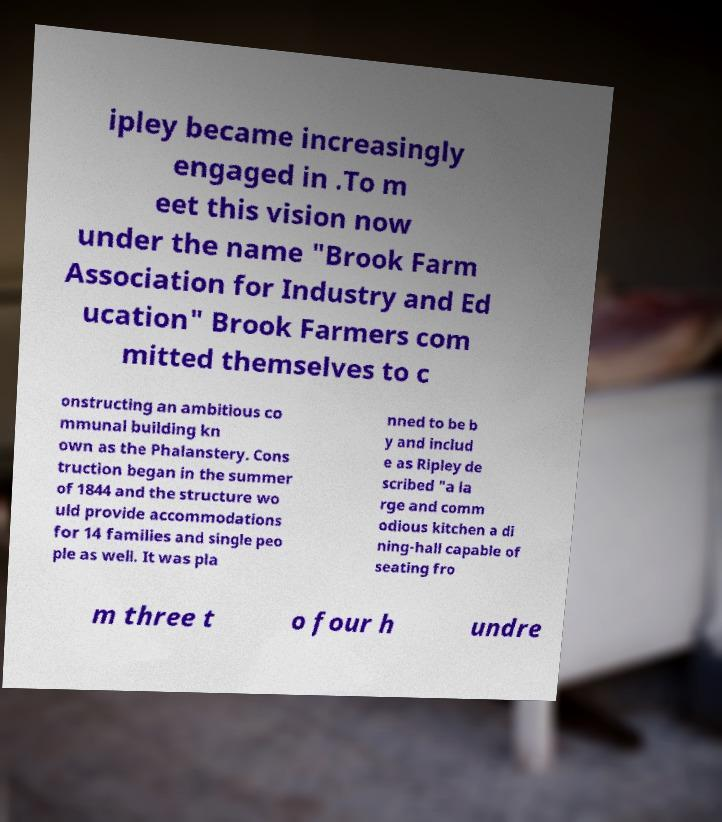Could you extract and type out the text from this image? ipley became increasingly engaged in .To m eet this vision now under the name "Brook Farm Association for Industry and Ed ucation" Brook Farmers com mitted themselves to c onstructing an ambitious co mmunal building kn own as the Phalanstery. Cons truction began in the summer of 1844 and the structure wo uld provide accommodations for 14 families and single peo ple as well. It was pla nned to be b y and includ e as Ripley de scribed "a la rge and comm odious kitchen a di ning-hall capable of seating fro m three t o four h undre 